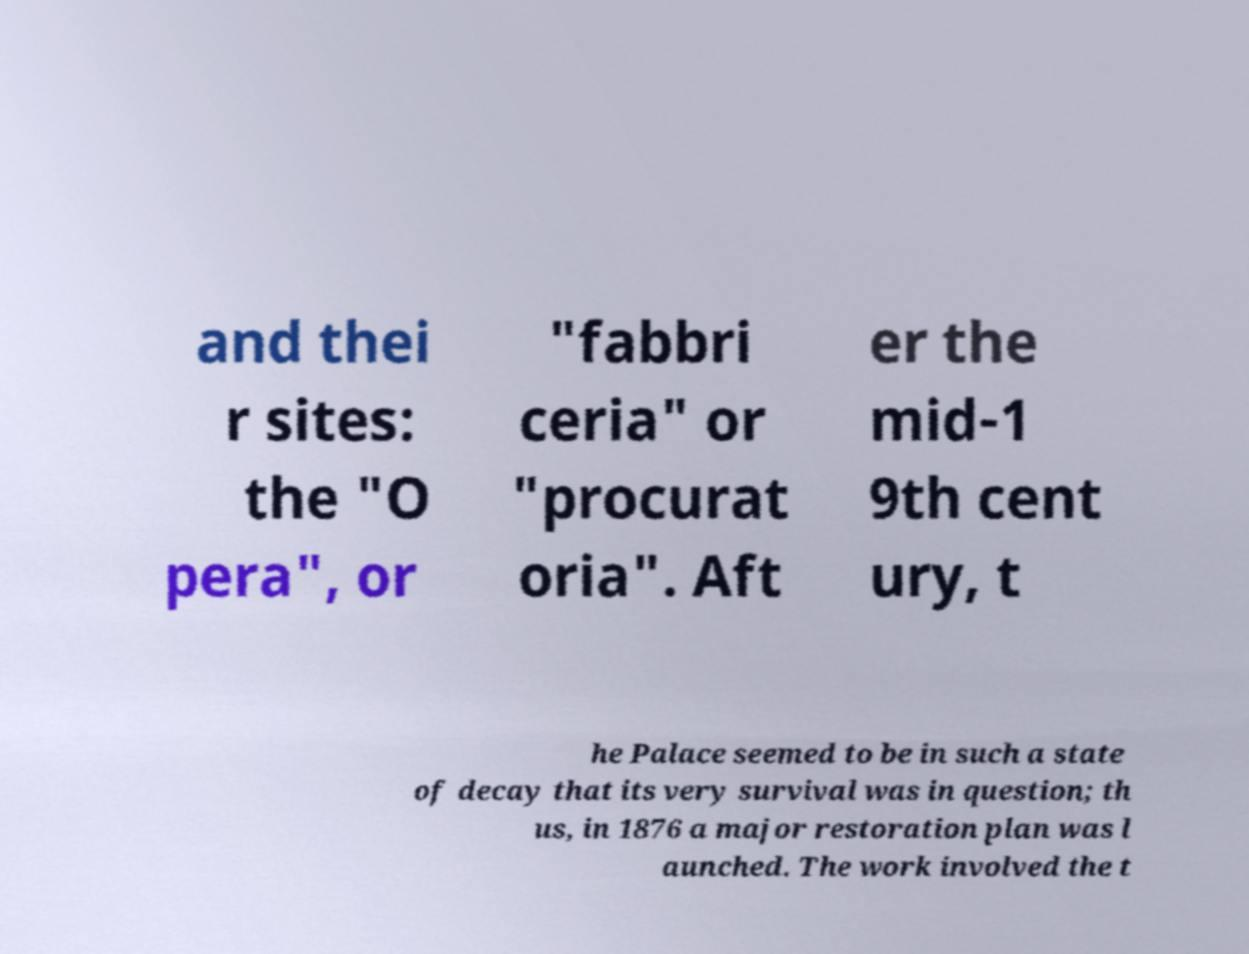Please read and relay the text visible in this image. What does it say? and thei r sites: the "O pera", or "fabbri ceria" or "procurat oria". Aft er the mid-1 9th cent ury, t he Palace seemed to be in such a state of decay that its very survival was in question; th us, in 1876 a major restoration plan was l aunched. The work involved the t 